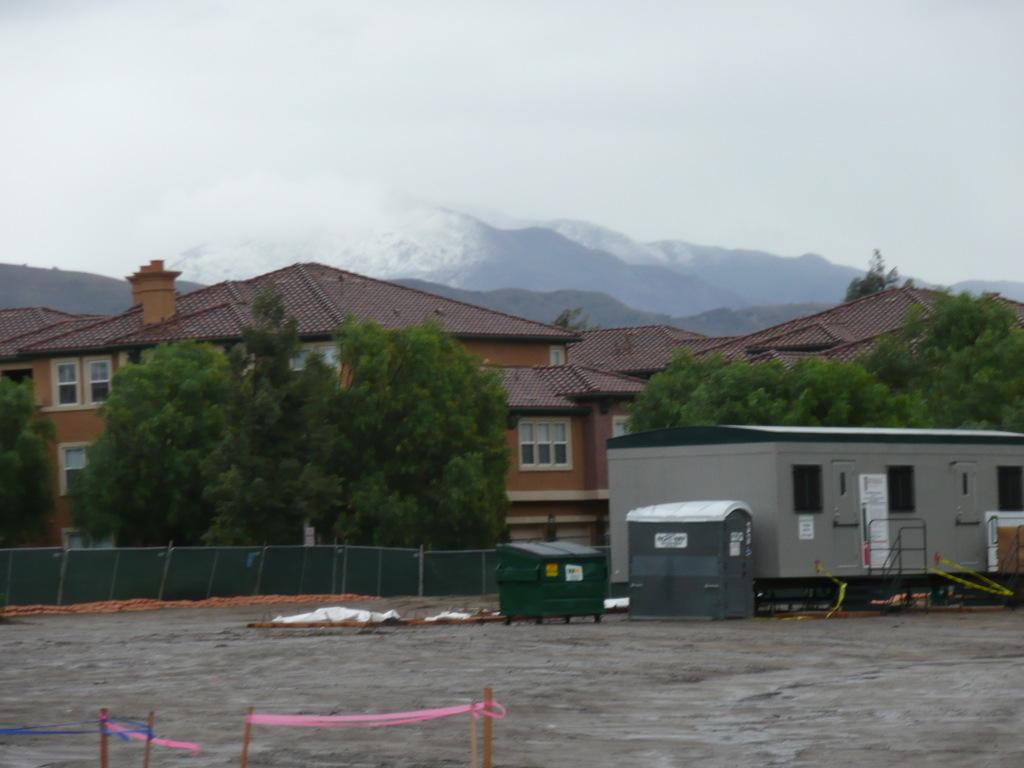What type of structures can be seen in the image? There are buildings in the image. What natural elements are present in the image? There are trees and mountains in the image. What is visible in the sky in the image? The sky is visible in the image. What type of barrier can be seen in the image? There is a fence in the image. What objects are on the ground in the image? There are objects on the ground in the image. Can you tell me how many crates are present in the image? There is no crate present in the image. What type of pain is being experienced by the trees in the image? There is no indication of pain in the image; the trees are simply present in the natural environment. 